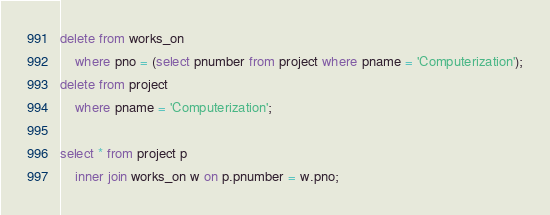<code> <loc_0><loc_0><loc_500><loc_500><_SQL_>delete from works_on
    where pno = (select pnumber from project where pname = 'Computerization');
delete from project
	where pname = 'Computerization';
    
select * from project p
	inner join works_on w on p.pnumber = w.pno;</code> 